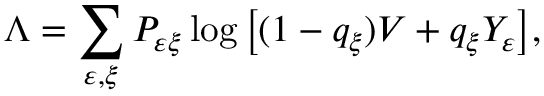<formula> <loc_0><loc_0><loc_500><loc_500>\Lambda = \sum _ { \varepsilon , \xi } P _ { \varepsilon \xi } \log \left [ ( 1 - q _ { \xi } ) V + q _ { \xi } Y _ { \varepsilon } \right ] ,</formula> 